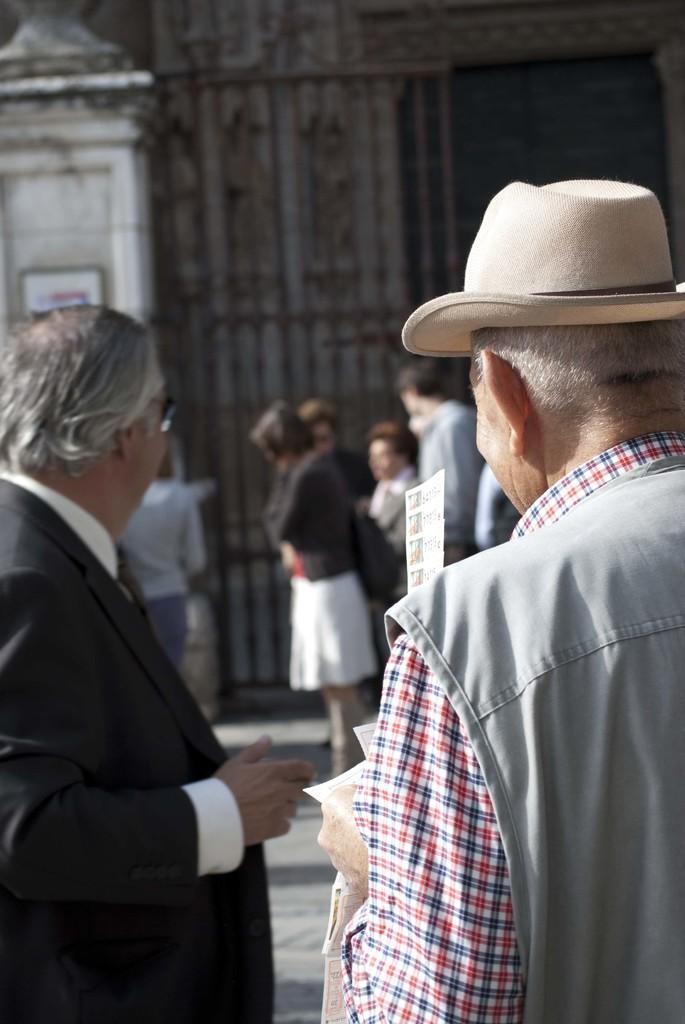What is the main subject of the picture? The main subject of the picture is people. Can you describe the man on the right side of the picture? There is a man wearing a hat on the right side of the picture. What about the person on the left side of the picture? There is a person wearing a coat on the left side of the picture. What is the zephyr doing in the picture? There is no mention of a zephyr in the image, as it is a gentle breeze and not a visible object or person. 